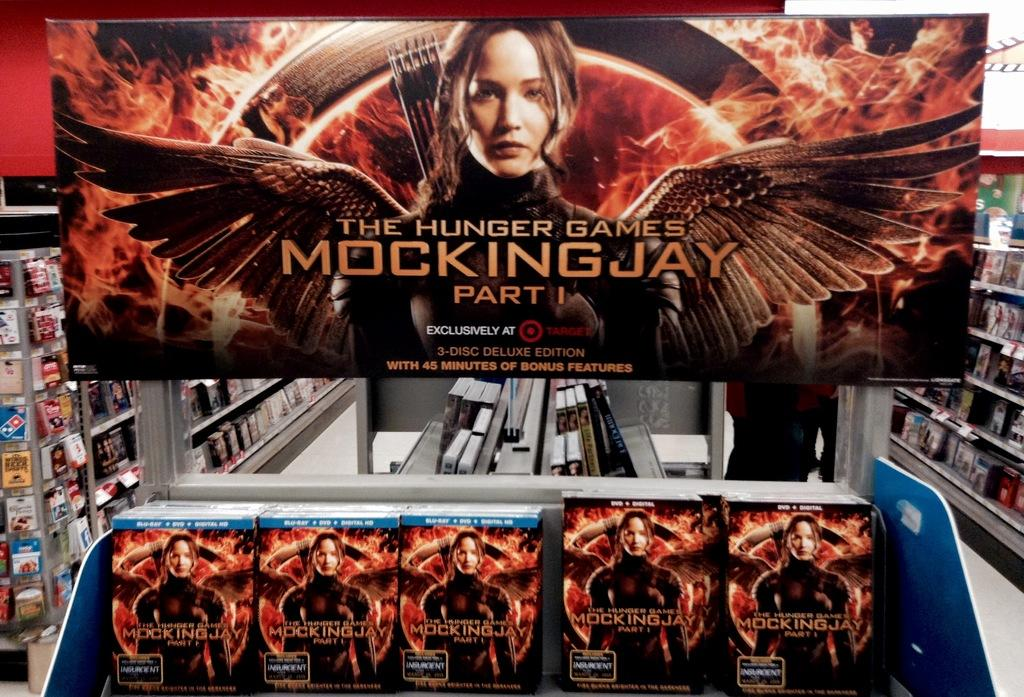<image>
Write a terse but informative summary of the picture. A display for the movie Mockingjay part 1 is set up in a store. 